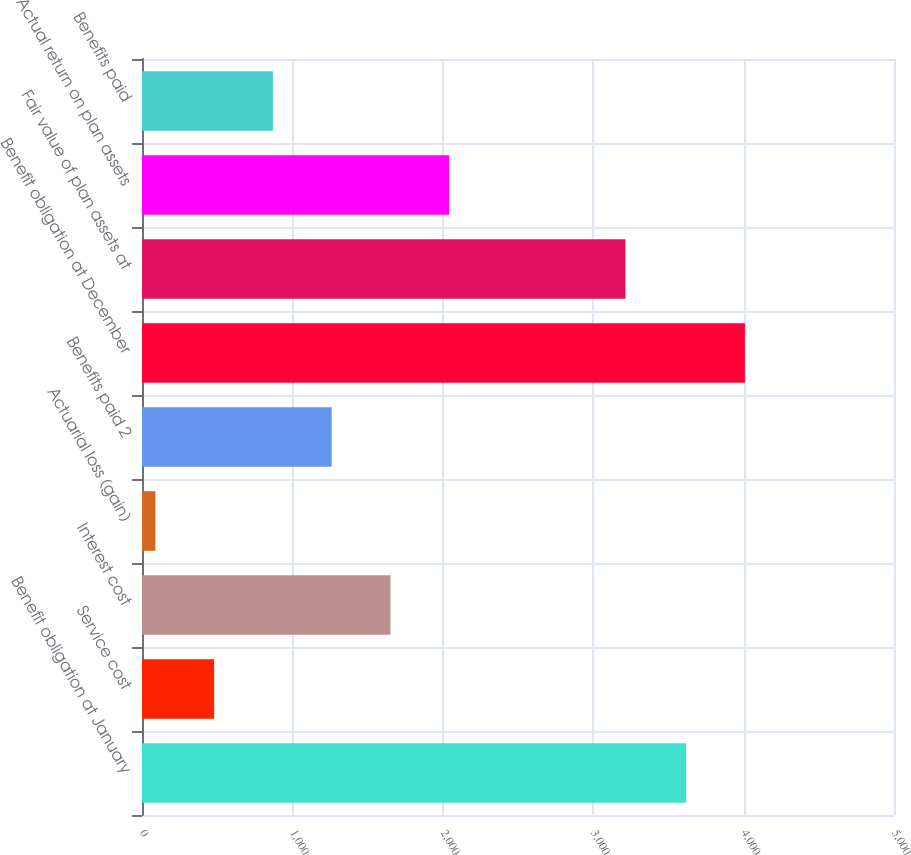<chart> <loc_0><loc_0><loc_500><loc_500><bar_chart><fcel>Benefit obligation at January<fcel>Service cost<fcel>Interest cost<fcel>Actuarial loss (gain)<fcel>Benefits paid 2<fcel>Benefit obligation at December<fcel>Fair value of plan assets at<fcel>Actual return on plan assets<fcel>Benefits paid<nl><fcel>3618<fcel>479.7<fcel>1651.8<fcel>89<fcel>1261.1<fcel>4008.7<fcel>3214.6<fcel>2042.5<fcel>870.4<nl></chart> 